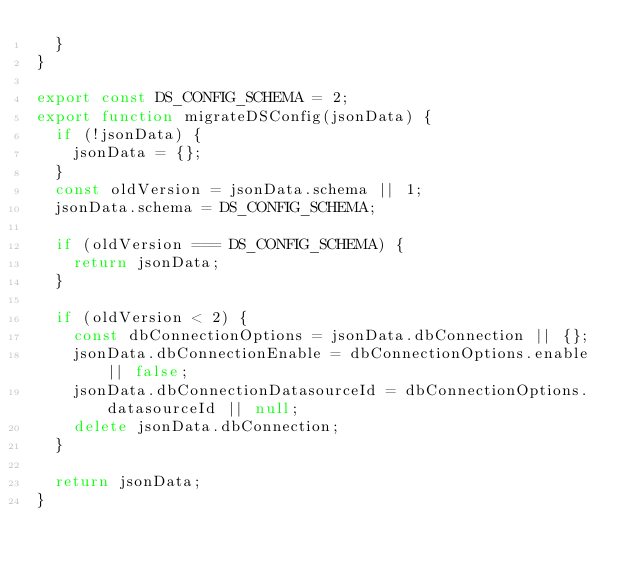Convert code to text. <code><loc_0><loc_0><loc_500><loc_500><_TypeScript_>  }
}

export const DS_CONFIG_SCHEMA = 2;
export function migrateDSConfig(jsonData) {
  if (!jsonData) {
    jsonData = {};
  }
  const oldVersion = jsonData.schema || 1;
  jsonData.schema = DS_CONFIG_SCHEMA;

  if (oldVersion === DS_CONFIG_SCHEMA) {
    return jsonData;
  }

  if (oldVersion < 2) {
    const dbConnectionOptions = jsonData.dbConnection || {};
    jsonData.dbConnectionEnable = dbConnectionOptions.enable || false;
    jsonData.dbConnectionDatasourceId = dbConnectionOptions.datasourceId || null;
    delete jsonData.dbConnection;
  }

  return jsonData;
}
</code> 